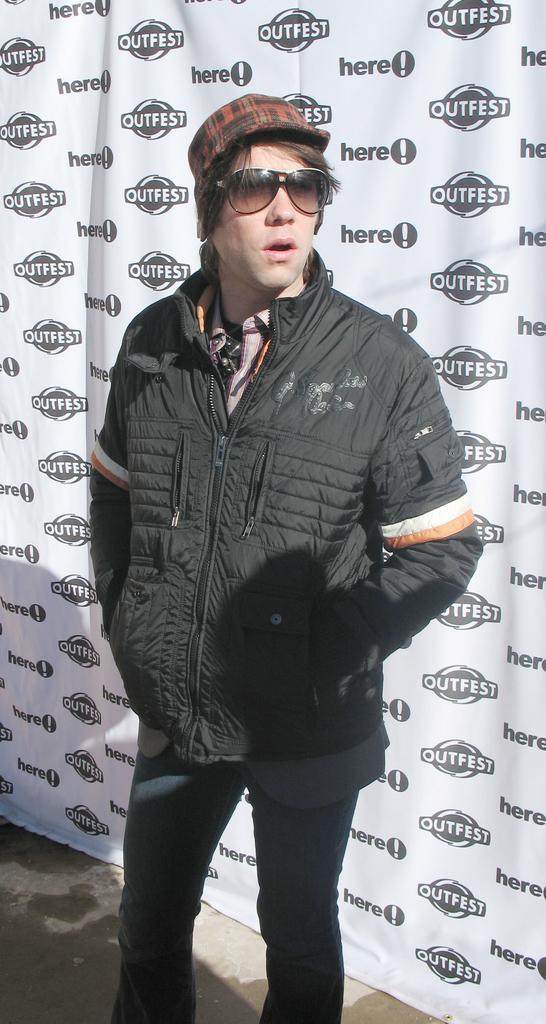Please provide a concise description of this image. In this image we can see a person wearing a jacket and a cap. In the background of the image there is a white color banner with some text. 